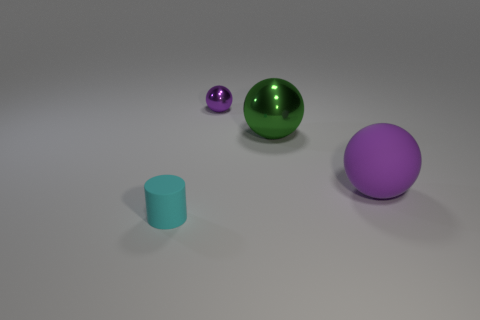How many large objects are either cylinders or blue matte spheres?
Your response must be concise. 0. What size is the matte thing in front of the matte thing right of the rubber thing that is to the left of the small purple thing?
Your answer should be compact. Small. How many cyan cylinders are the same size as the purple metallic ball?
Ensure brevity in your answer.  1. What number of things are matte spheres or spheres that are right of the green object?
Keep it short and to the point. 1. The cyan thing has what shape?
Your response must be concise. Cylinder. Is the color of the tiny metal ball the same as the tiny rubber cylinder?
Provide a short and direct response. No. The sphere that is the same size as the cyan cylinder is what color?
Provide a succinct answer. Purple. How many gray things are either matte cylinders or metal spheres?
Your answer should be compact. 0. Is the number of brown metal balls greater than the number of large green shiny things?
Offer a very short reply. No. There is a sphere that is in front of the large green metallic sphere; is its size the same as the matte thing in front of the big matte object?
Give a very brief answer. No. 